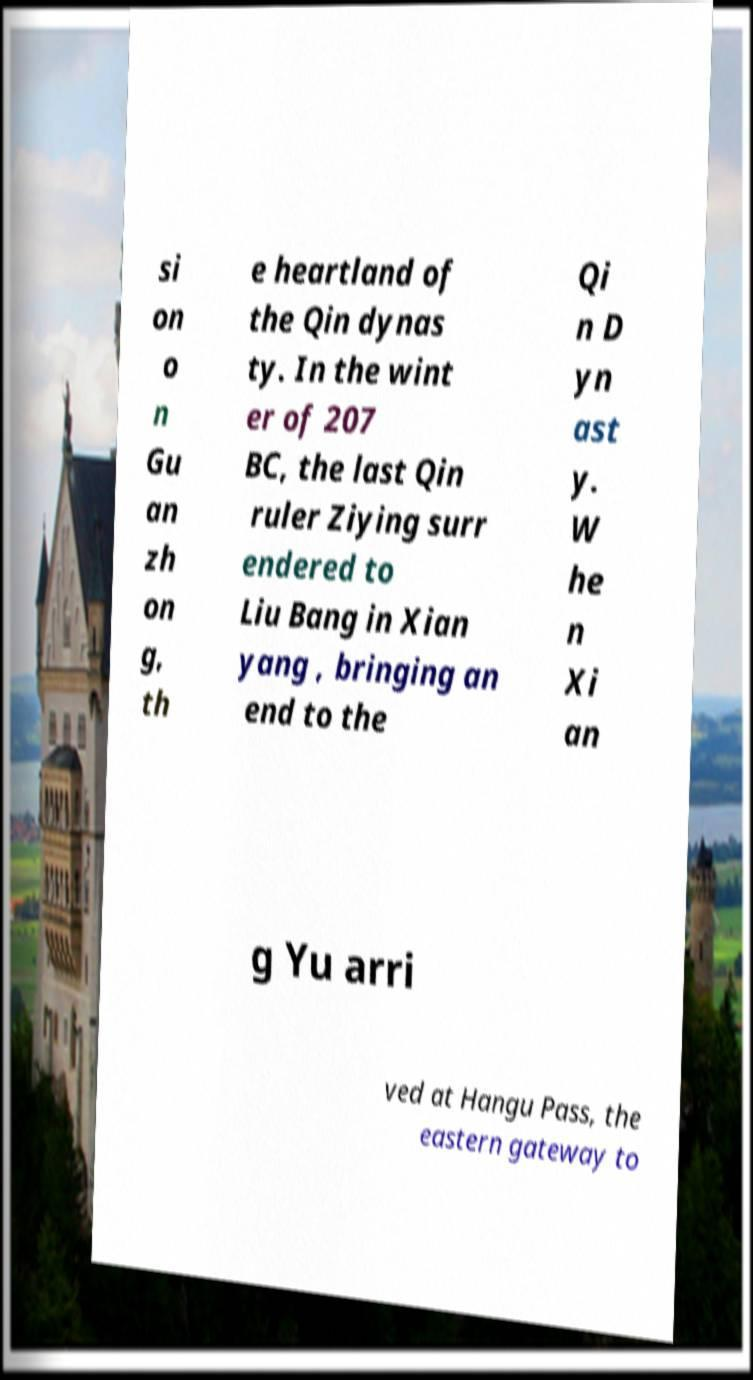Can you read and provide the text displayed in the image?This photo seems to have some interesting text. Can you extract and type it out for me? si on o n Gu an zh on g, th e heartland of the Qin dynas ty. In the wint er of 207 BC, the last Qin ruler Ziying surr endered to Liu Bang in Xian yang , bringing an end to the Qi n D yn ast y. W he n Xi an g Yu arri ved at Hangu Pass, the eastern gateway to 